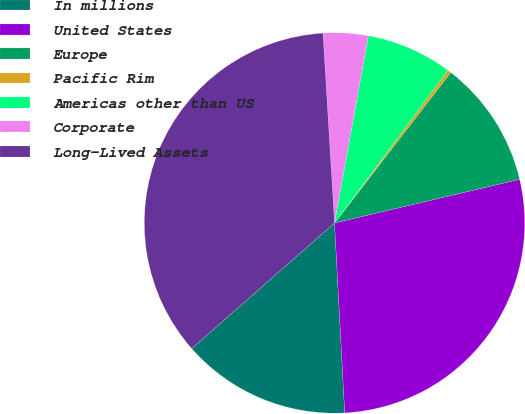<chart> <loc_0><loc_0><loc_500><loc_500><pie_chart><fcel>In millions<fcel>United States<fcel>Europe<fcel>Pacific Rim<fcel>Americas other than US<fcel>Corporate<fcel>Long-Lived Assets<nl><fcel>14.38%<fcel>27.83%<fcel>10.85%<fcel>0.29%<fcel>7.33%<fcel>3.81%<fcel>35.51%<nl></chart> 